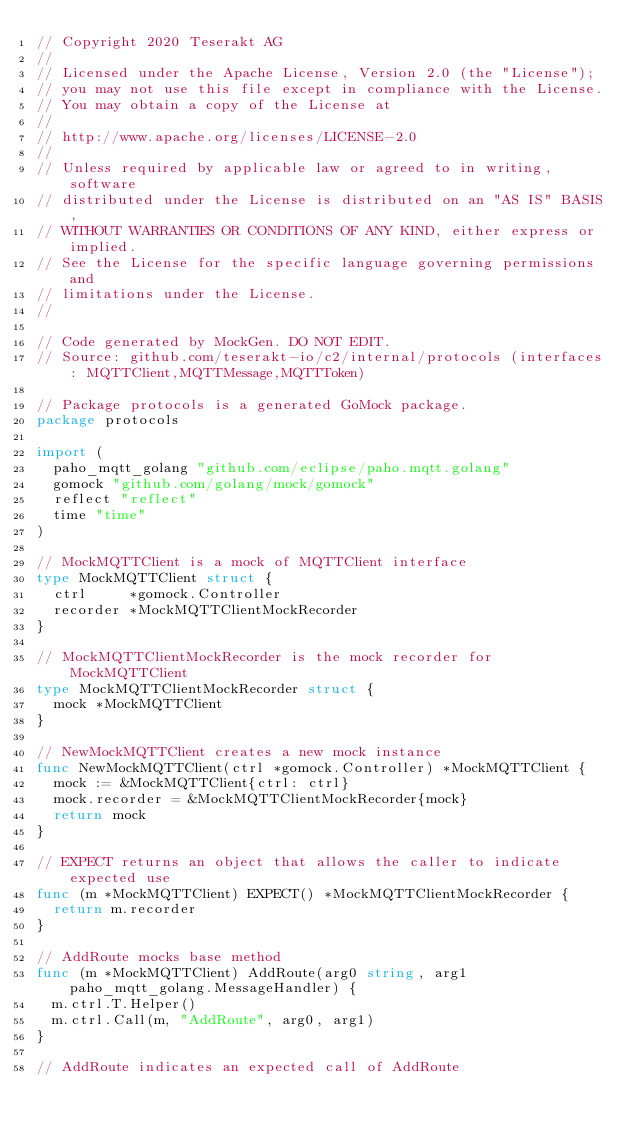Convert code to text. <code><loc_0><loc_0><loc_500><loc_500><_Go_>// Copyright 2020 Teserakt AG
//
// Licensed under the Apache License, Version 2.0 (the "License");
// you may not use this file except in compliance with the License.
// You may obtain a copy of the License at
//
// http://www.apache.org/licenses/LICENSE-2.0
//
// Unless required by applicable law or agreed to in writing, software
// distributed under the License is distributed on an "AS IS" BASIS,
// WITHOUT WARRANTIES OR CONDITIONS OF ANY KIND, either express or implied.
// See the License for the specific language governing permissions and
// limitations under the License.
//

// Code generated by MockGen. DO NOT EDIT.
// Source: github.com/teserakt-io/c2/internal/protocols (interfaces: MQTTClient,MQTTMessage,MQTTToken)

// Package protocols is a generated GoMock package.
package protocols

import (
	paho_mqtt_golang "github.com/eclipse/paho.mqtt.golang"
	gomock "github.com/golang/mock/gomock"
	reflect "reflect"
	time "time"
)

// MockMQTTClient is a mock of MQTTClient interface
type MockMQTTClient struct {
	ctrl     *gomock.Controller
	recorder *MockMQTTClientMockRecorder
}

// MockMQTTClientMockRecorder is the mock recorder for MockMQTTClient
type MockMQTTClientMockRecorder struct {
	mock *MockMQTTClient
}

// NewMockMQTTClient creates a new mock instance
func NewMockMQTTClient(ctrl *gomock.Controller) *MockMQTTClient {
	mock := &MockMQTTClient{ctrl: ctrl}
	mock.recorder = &MockMQTTClientMockRecorder{mock}
	return mock
}

// EXPECT returns an object that allows the caller to indicate expected use
func (m *MockMQTTClient) EXPECT() *MockMQTTClientMockRecorder {
	return m.recorder
}

// AddRoute mocks base method
func (m *MockMQTTClient) AddRoute(arg0 string, arg1 paho_mqtt_golang.MessageHandler) {
	m.ctrl.T.Helper()
	m.ctrl.Call(m, "AddRoute", arg0, arg1)
}

// AddRoute indicates an expected call of AddRoute</code> 